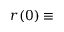<formula> <loc_0><loc_0><loc_500><loc_500>r ( 0 ) \equiv</formula> 